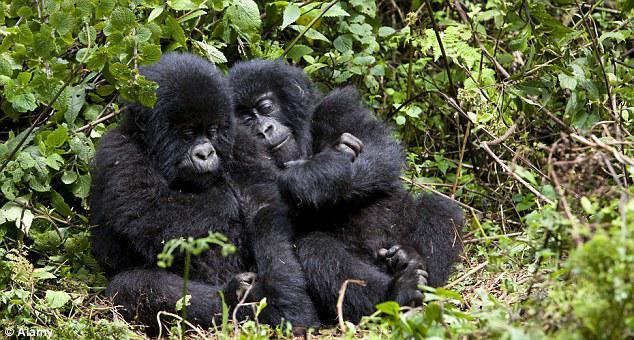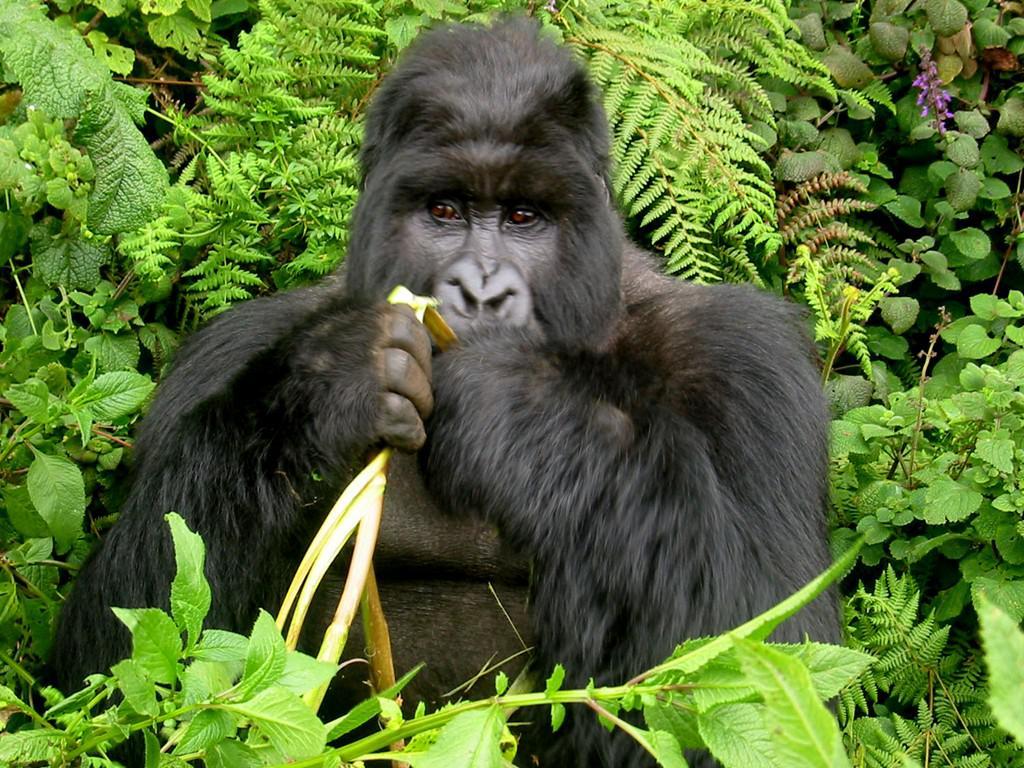The first image is the image on the left, the second image is the image on the right. Considering the images on both sides, is "There is a group of gorillas in both images." valid? Answer yes or no. No. The first image is the image on the left, the second image is the image on the right. Analyze the images presented: Is the assertion "The gorilla in the foreground of the right image has both its hands at mouth level, with fingers curled." valid? Answer yes or no. Yes. 